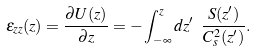<formula> <loc_0><loc_0><loc_500><loc_500>\varepsilon _ { z z } ( z ) = \frac { \partial U ( z ) } { \partial z } = - \int _ { - \infty } ^ { z } d z ^ { \prime } \ \frac { S ( z ^ { \prime } ) } { C _ { s } ^ { 2 } ( z ^ { \prime } ) } .</formula> 